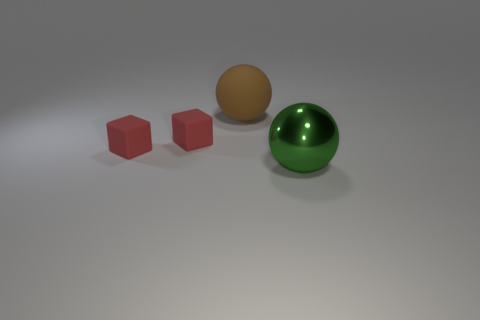Add 3 big green metal balls. How many objects exist? 7 Add 2 large brown spheres. How many large brown spheres exist? 3 Subtract 0 purple balls. How many objects are left? 4 Subtract all large green metal things. Subtract all green spheres. How many objects are left? 2 Add 3 tiny matte objects. How many tiny matte objects are left? 5 